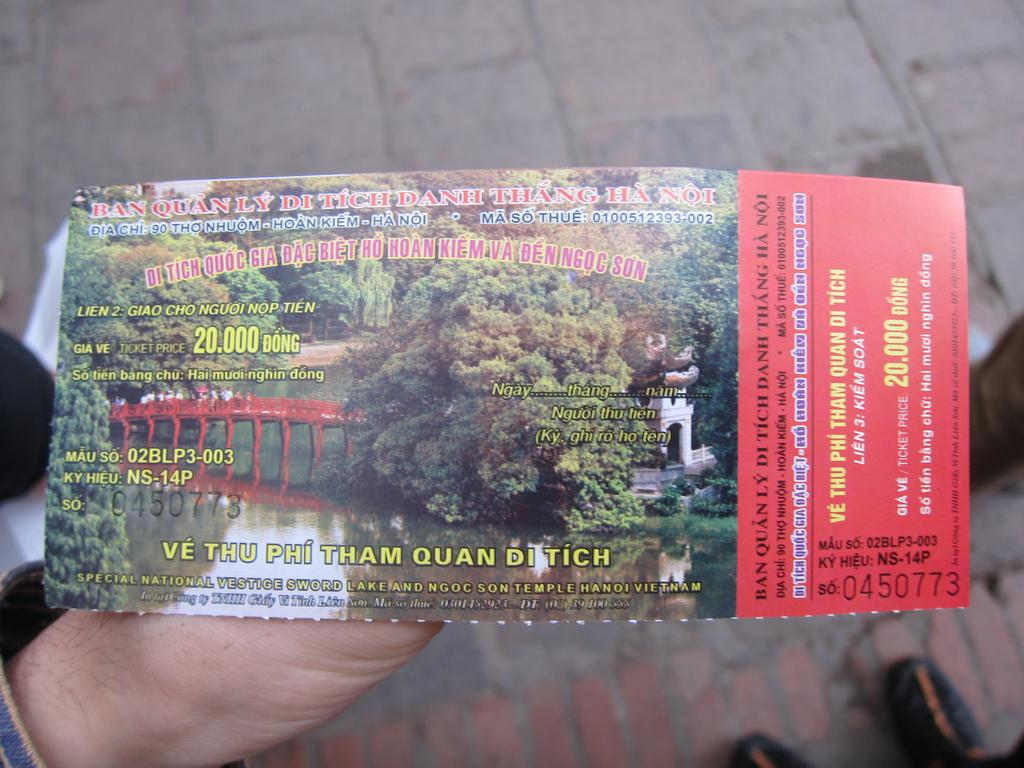<image>
Provide a brief description of the given image. Ve Thu Phi Tham Quan Ditich will be seen by ticket holder 0450773. 